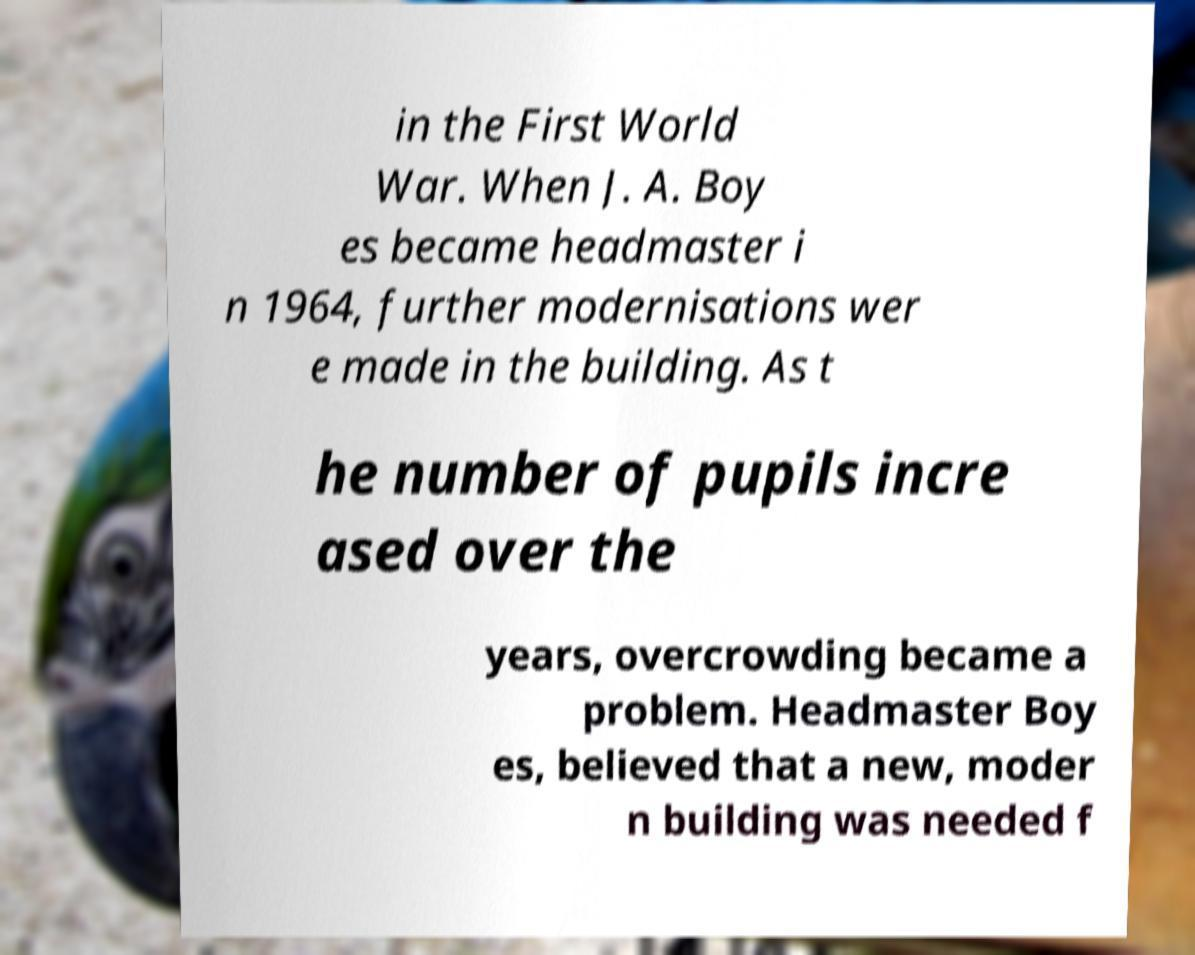For documentation purposes, I need the text within this image transcribed. Could you provide that? in the First World War. When J. A. Boy es became headmaster i n 1964, further modernisations wer e made in the building. As t he number of pupils incre ased over the years, overcrowding became a problem. Headmaster Boy es, believed that a new, moder n building was needed f 